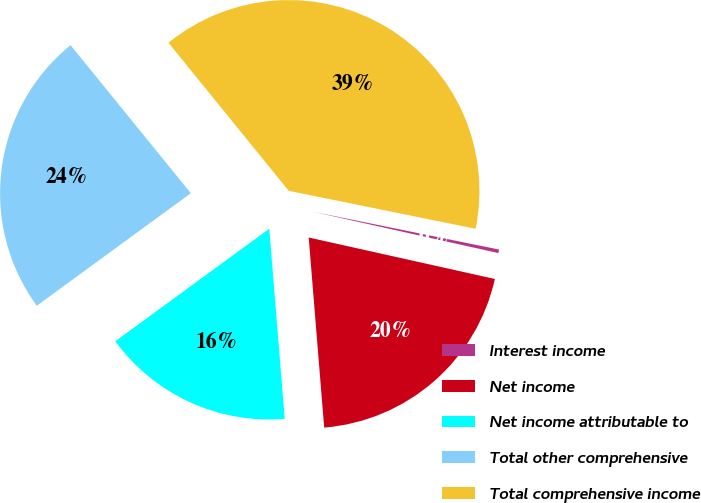<chart> <loc_0><loc_0><loc_500><loc_500><pie_chart><fcel>Interest income<fcel>Net income<fcel>Net income attributable to<fcel>Total other comprehensive<fcel>Total comprehensive income<nl><fcel>0.3%<fcel>20.22%<fcel>16.25%<fcel>24.19%<fcel>39.05%<nl></chart> 